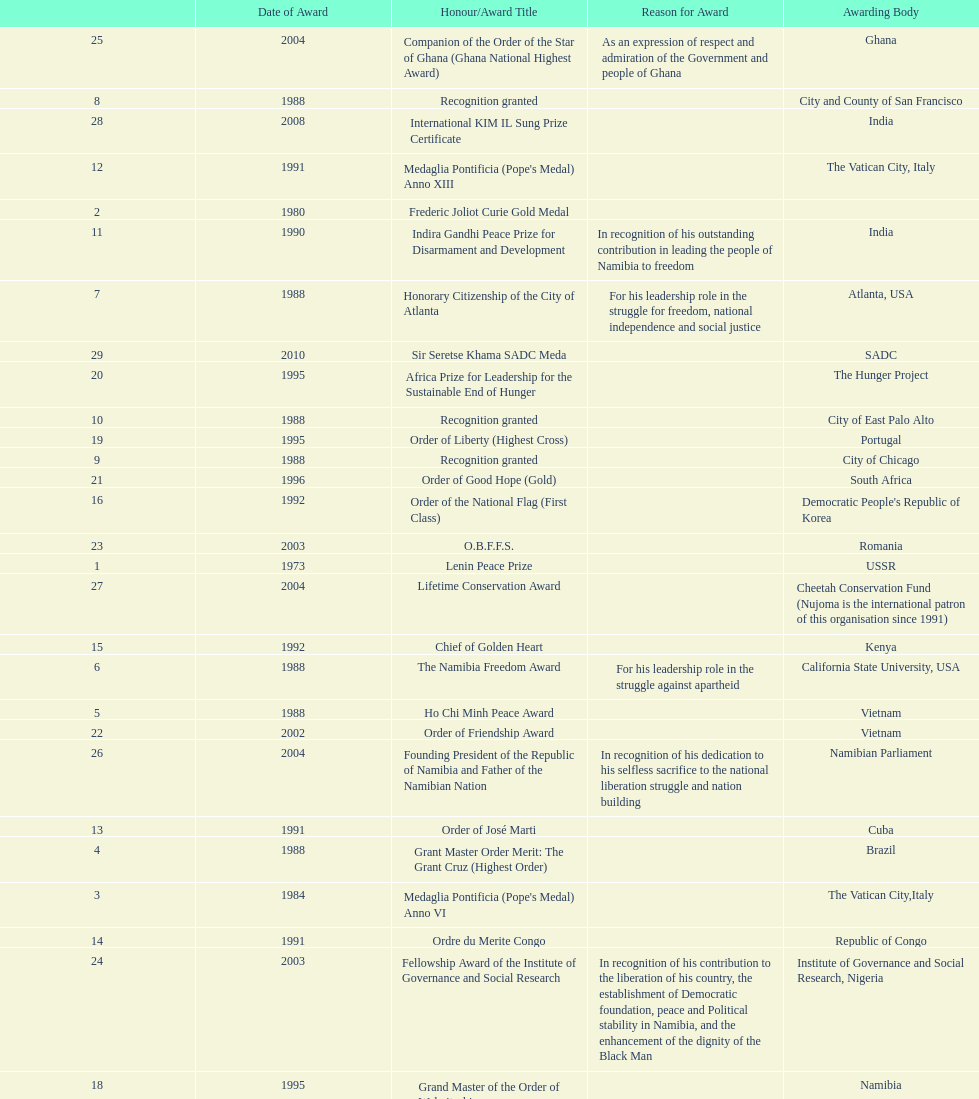Did nujoma win the o.b.f.f.s. award in romania or ghana? Romania. 